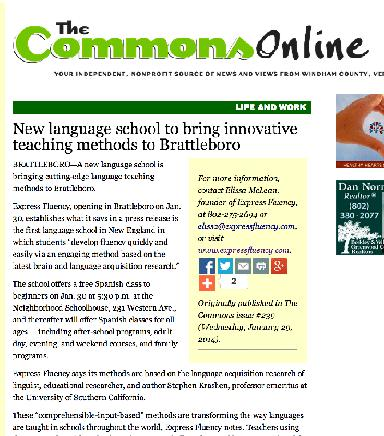What type of language classes are offered? According to the image, the school initially offers free Spanish classes specifically for beginners. There is an intent to broaden the scope to include varied age groups ranging from pre-kindergarten children to adults, making language learning accessible to a diverse demographic. 